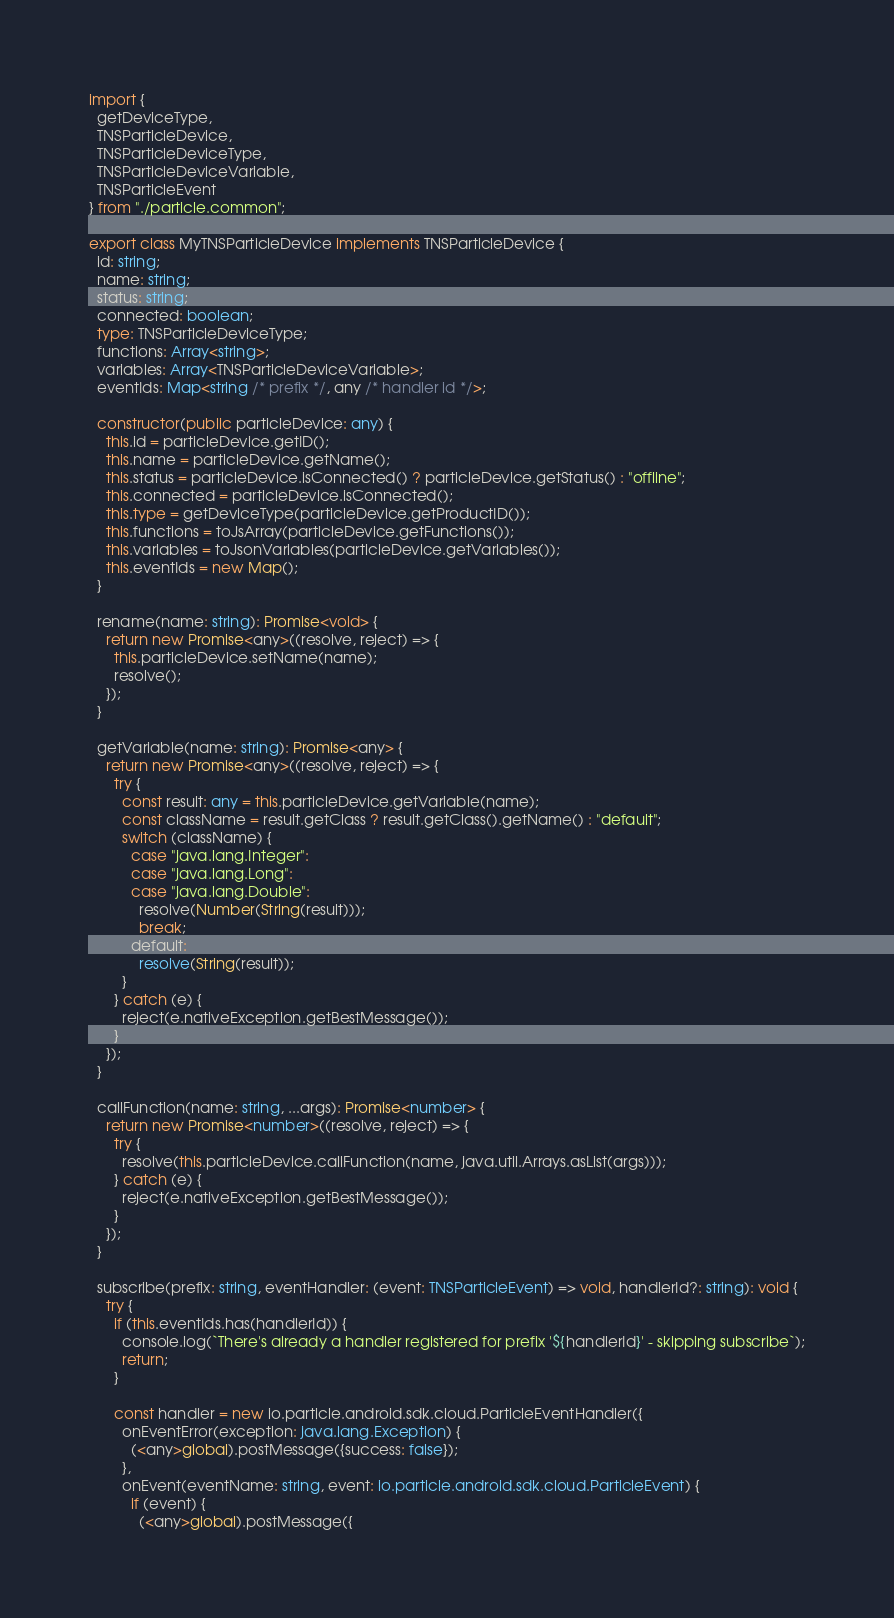<code> <loc_0><loc_0><loc_500><loc_500><_TypeScript_>import {
  getDeviceType,
  TNSParticleDevice,
  TNSParticleDeviceType,
  TNSParticleDeviceVariable,
  TNSParticleEvent
} from "./particle.common";

export class MyTNSParticleDevice implements TNSParticleDevice {
  id: string;
  name: string;
  status: string;
  connected: boolean;
  type: TNSParticleDeviceType;
  functions: Array<string>;
  variables: Array<TNSParticleDeviceVariable>;
  eventIds: Map<string /* prefix */, any /* handler id */>;

  constructor(public particleDevice: any) {
    this.id = particleDevice.getID();
    this.name = particleDevice.getName();
    this.status = particleDevice.isConnected() ? particleDevice.getStatus() : "offline";
    this.connected = particleDevice.isConnected();
    this.type = getDeviceType(particleDevice.getProductID());
    this.functions = toJsArray(particleDevice.getFunctions());
    this.variables = toJsonVariables(particleDevice.getVariables());
    this.eventIds = new Map();
  }

  rename(name: string): Promise<void> {
    return new Promise<any>((resolve, reject) => {
      this.particleDevice.setName(name);
      resolve();
    });
  }

  getVariable(name: string): Promise<any> {
    return new Promise<any>((resolve, reject) => {
      try {
        const result: any = this.particleDevice.getVariable(name);
        const className = result.getClass ? result.getClass().getName() : "default";
        switch (className) {
          case "java.lang.Integer":
          case "java.lang.Long":
          case "java.lang.Double":
            resolve(Number(String(result)));
            break;
          default:
            resolve(String(result));
        }
      } catch (e) {
        reject(e.nativeException.getBestMessage());
      }
    });
  }

  callFunction(name: string, ...args): Promise<number> {
    return new Promise<number>((resolve, reject) => {
      try {
        resolve(this.particleDevice.callFunction(name, java.util.Arrays.asList(args)));
      } catch (e) {
        reject(e.nativeException.getBestMessage());
      }
    });
  }

  subscribe(prefix: string, eventHandler: (event: TNSParticleEvent) => void, handlerId?: string): void {
    try {
      if (this.eventIds.has(handlerId)) {
        console.log(`There's already a handler registered for prefix '${handlerId}' - skipping subscribe`);
        return;
      }

      const handler = new io.particle.android.sdk.cloud.ParticleEventHandler({
        onEventError(exception: java.lang.Exception) {
          (<any>global).postMessage({success: false});
        },
        onEvent(eventName: string, event: io.particle.android.sdk.cloud.ParticleEvent) {
          if (event) {
            (<any>global).postMessage({</code> 